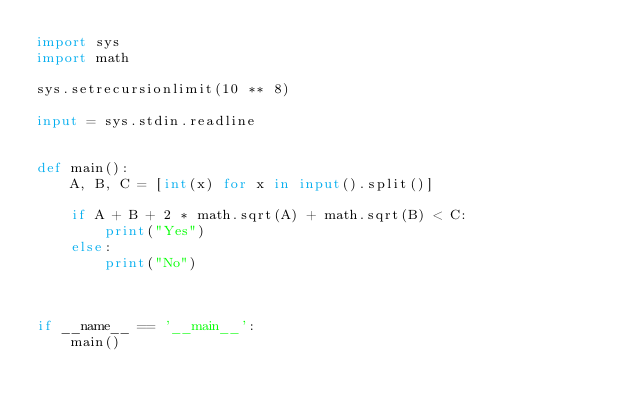Convert code to text. <code><loc_0><loc_0><loc_500><loc_500><_Python_>import sys
import math

sys.setrecursionlimit(10 ** 8)

input = sys.stdin.readline


def main():
    A, B, C = [int(x) for x in input().split()]

    if A + B + 2 * math.sqrt(A) + math.sqrt(B) < C:
        print("Yes")
    else:
        print("No")



if __name__ == '__main__':
    main()
</code> 